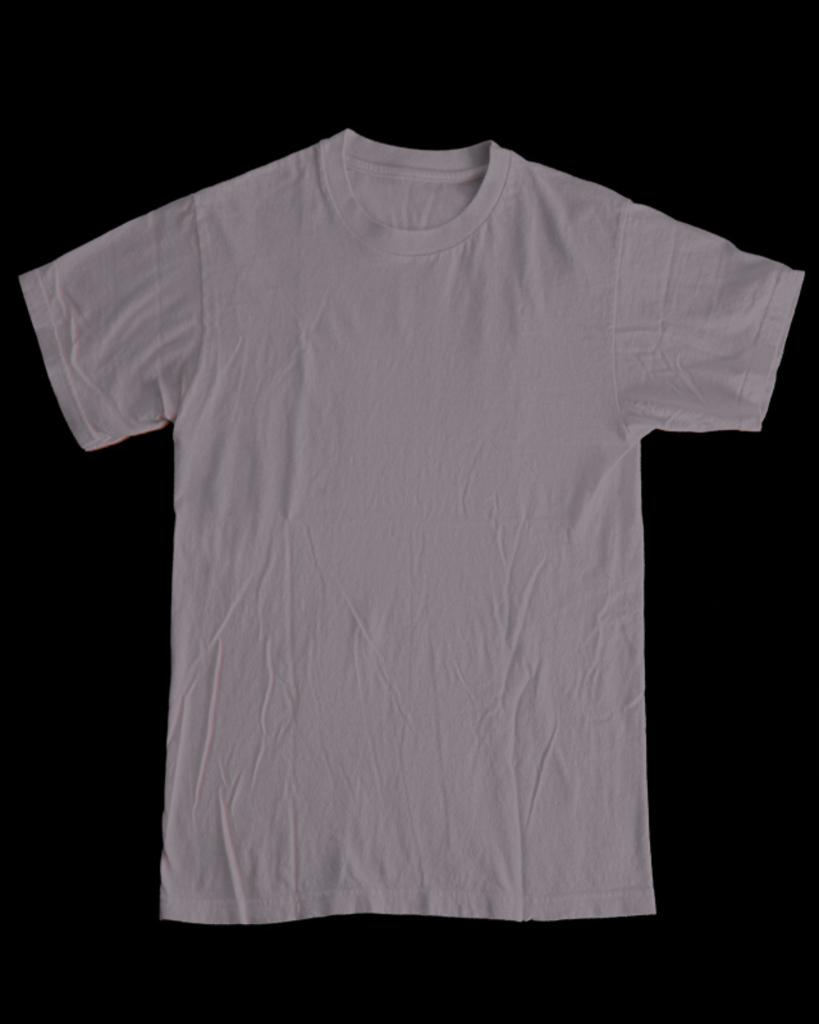What type of clothing item is visible in the image? There is a white t-shirt in the image. What color is the surface on which the t-shirt is placed? The t-shirt is on a black surface. Can you see any sparks coming from the t-shirt in the image? No, there are no sparks visible in the image. 